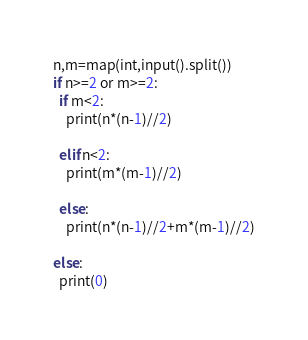Convert code to text. <code><loc_0><loc_0><loc_500><loc_500><_Python_>n,m=map(int,input().split())
if n>=2 or m>=2:
  if m<2:
    print(n*(n-1)//2)
    
  elif n<2:
    print(m*(m-1)//2)
    
  else:
    print(n*(n-1)//2+m*(m-1)//2)
    
else:
  print(0)</code> 